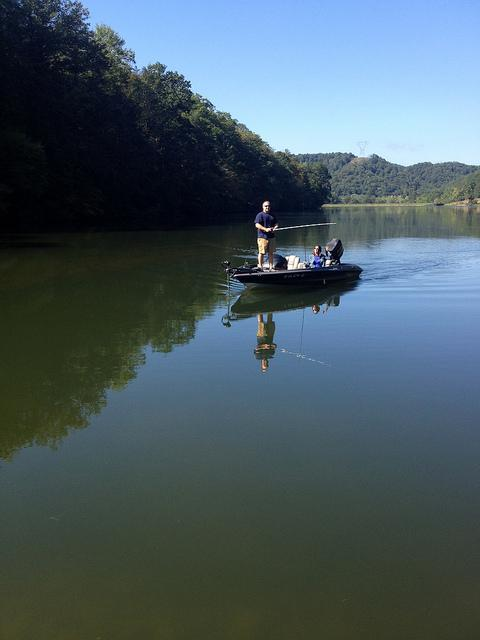How many people are sitting in the fishing boat on this day? two 